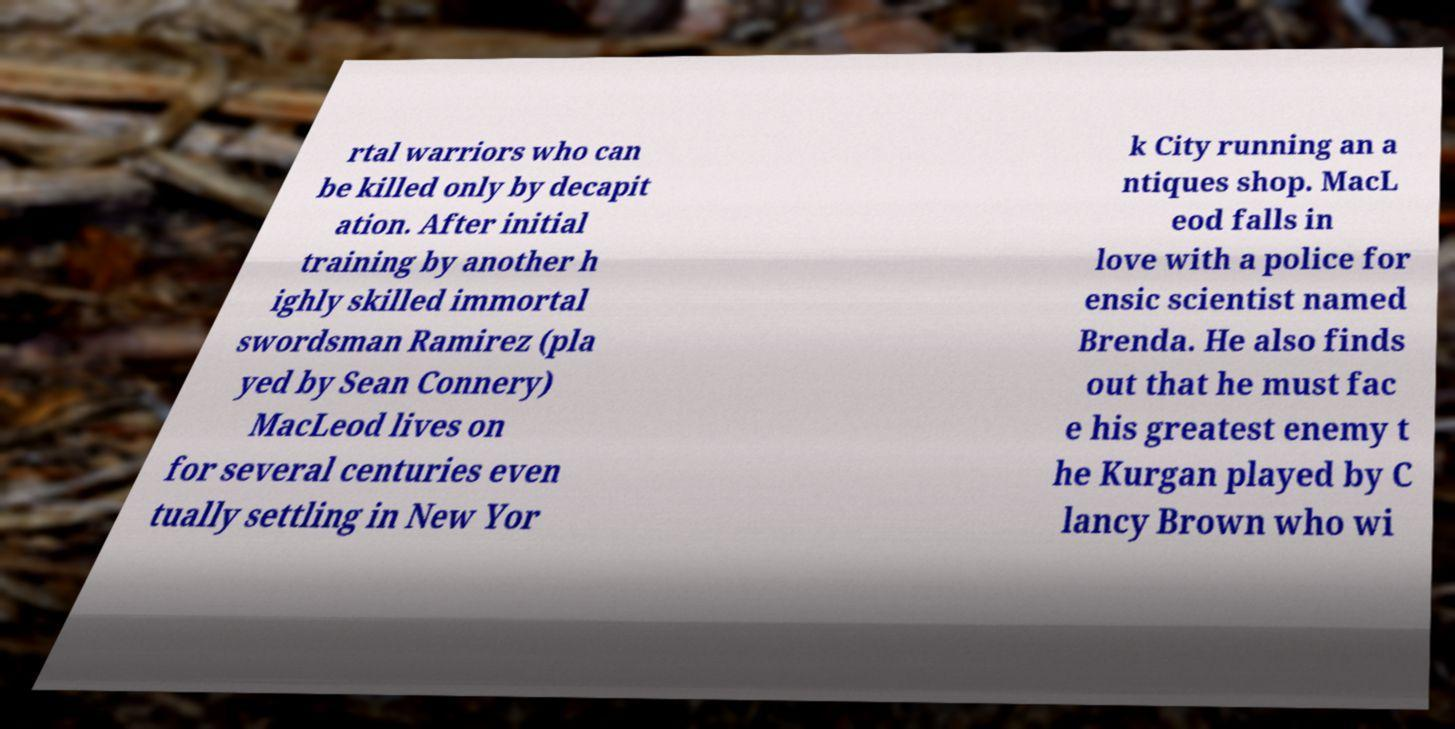Please identify and transcribe the text found in this image. rtal warriors who can be killed only by decapit ation. After initial training by another h ighly skilled immortal swordsman Ramirez (pla yed by Sean Connery) MacLeod lives on for several centuries even tually settling in New Yor k City running an a ntiques shop. MacL eod falls in love with a police for ensic scientist named Brenda. He also finds out that he must fac e his greatest enemy t he Kurgan played by C lancy Brown who wi 